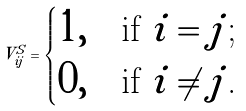Convert formula to latex. <formula><loc_0><loc_0><loc_500><loc_500>V ^ { S } _ { i j } = \begin{cases} 1 , & \text {if $i=j$;} \\ 0 , & \text {if $i\ne j$.} \end{cases}</formula> 